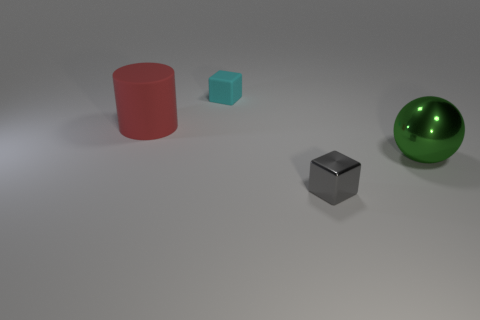Add 4 big green metal blocks. How many objects exist? 8 Subtract all balls. How many objects are left? 3 Subtract all small yellow metal blocks. Subtract all red rubber things. How many objects are left? 3 Add 1 rubber blocks. How many rubber blocks are left? 2 Add 4 big green balls. How many big green balls exist? 5 Subtract 0 purple cylinders. How many objects are left? 4 